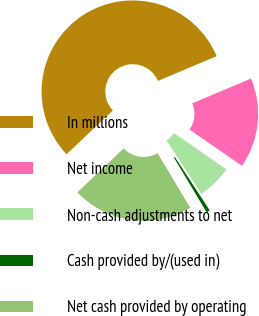Convert chart to OTSL. <chart><loc_0><loc_0><loc_500><loc_500><pie_chart><fcel>In millions<fcel>Net income<fcel>Non-cash adjustments to net<fcel>Cash provided by/(used in)<fcel>Net cash provided by operating<nl><fcel>55.72%<fcel>15.99%<fcel>6.15%<fcel>0.64%<fcel>21.49%<nl></chart> 